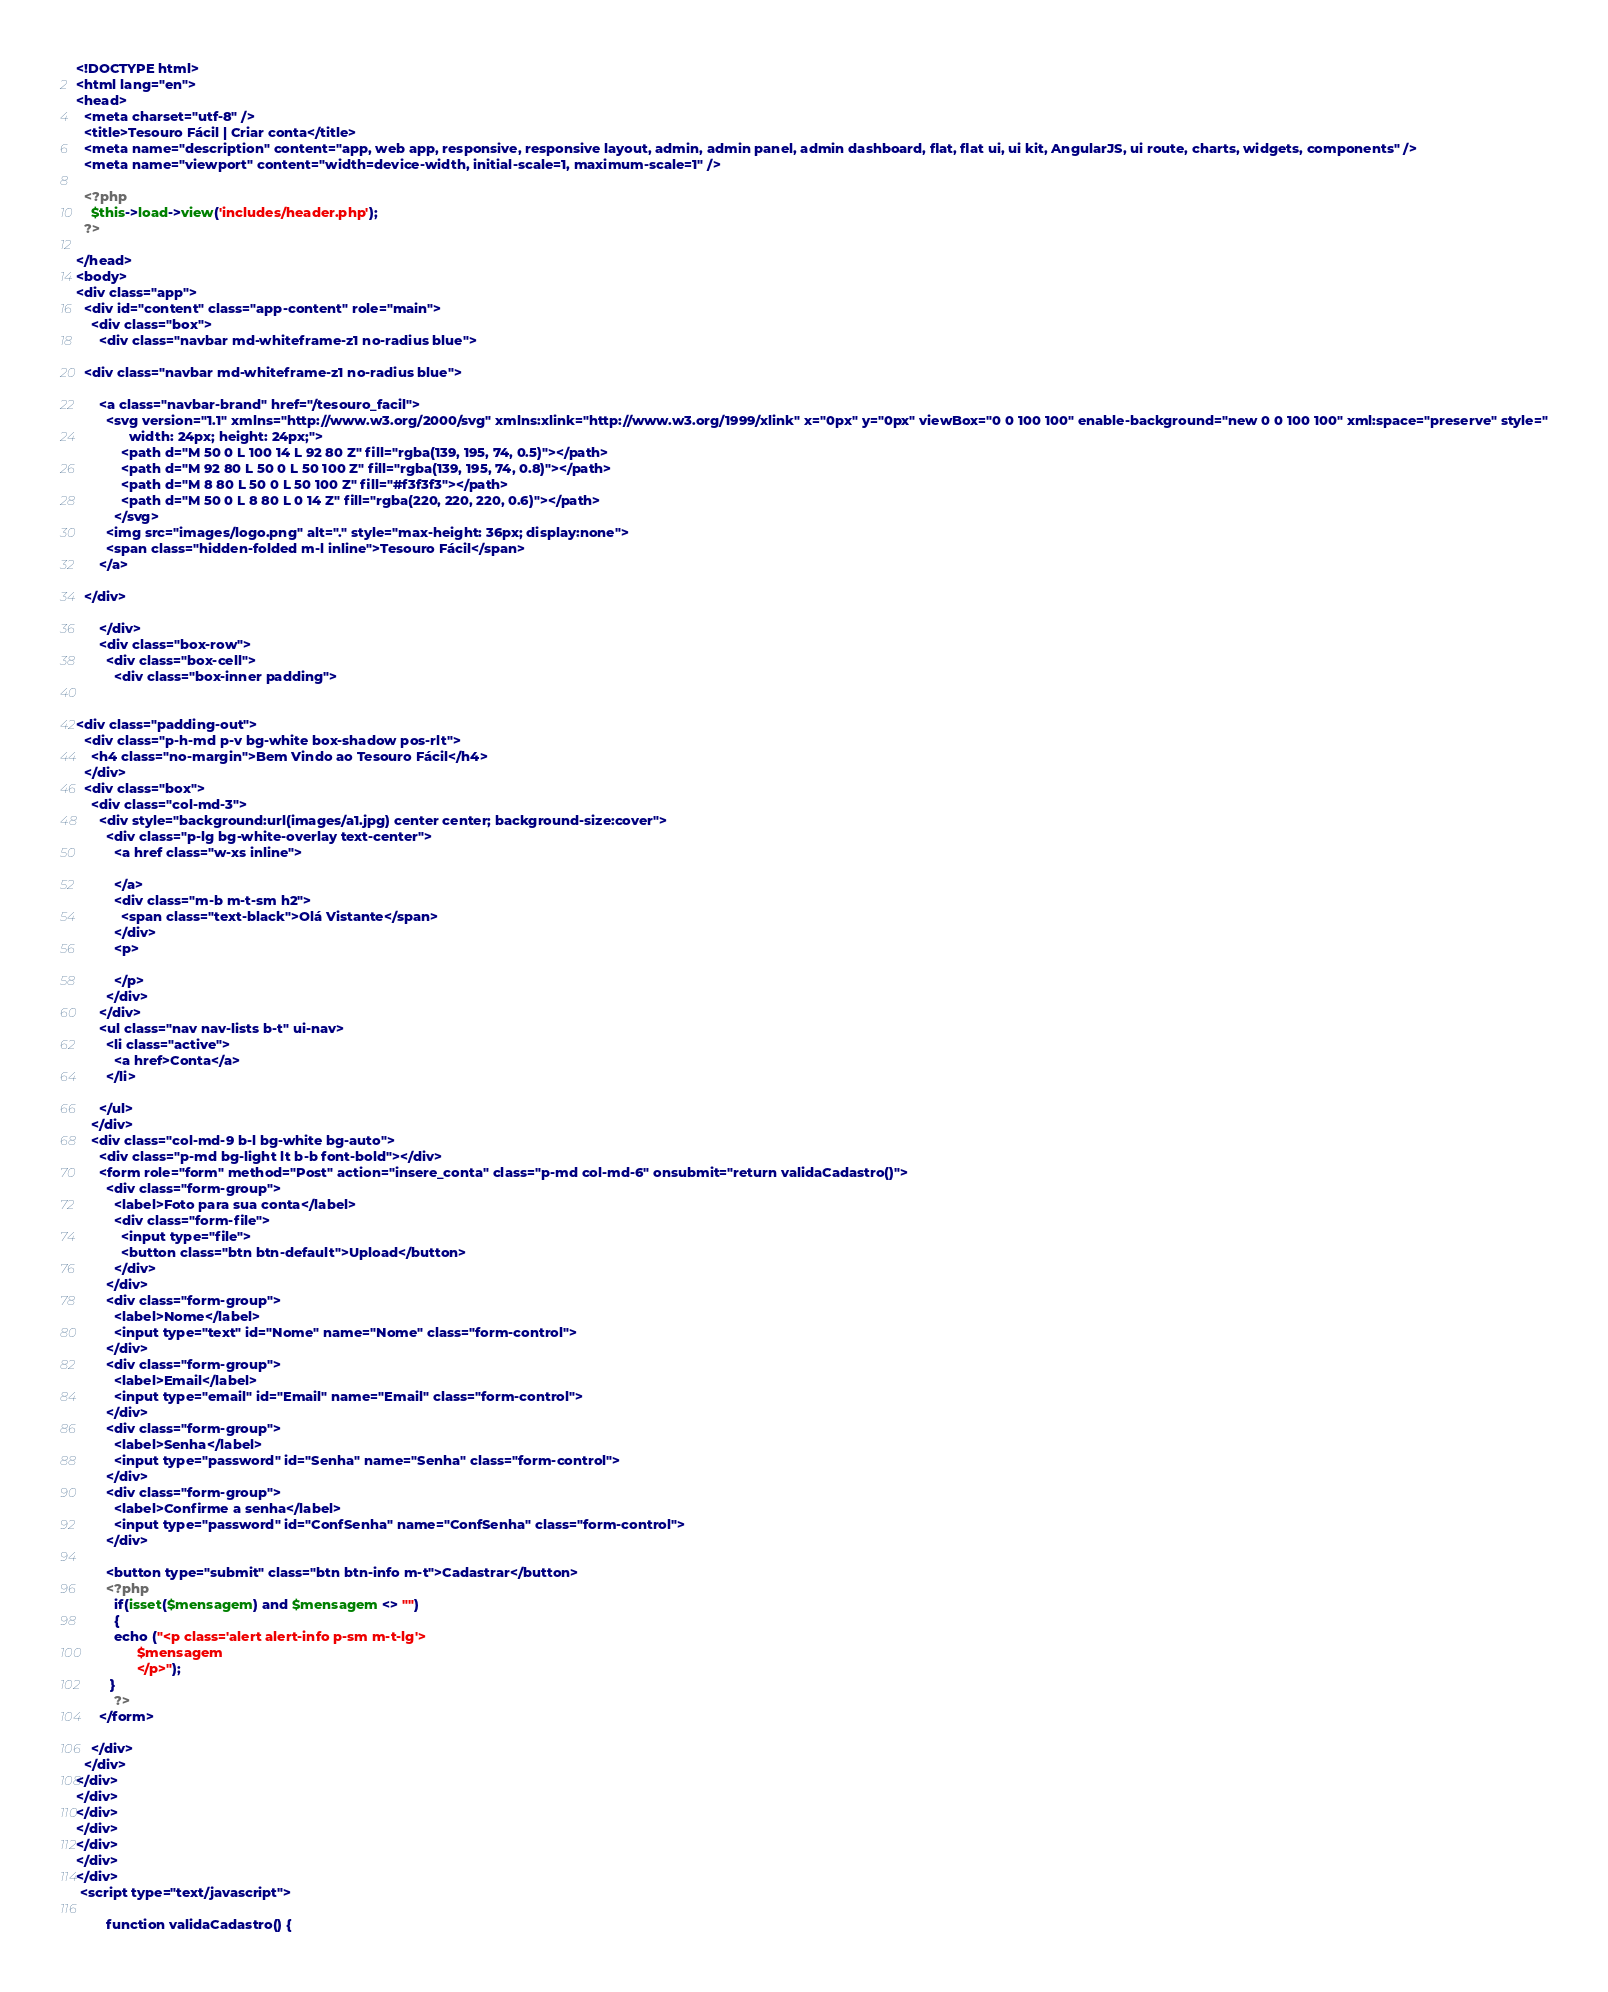<code> <loc_0><loc_0><loc_500><loc_500><_PHP_><!DOCTYPE html>
<html lang="en">
<head>
  <meta charset="utf-8" />
  <title>Tesouro Fácil | Criar conta</title>
  <meta name="description" content="app, web app, responsive, responsive layout, admin, admin panel, admin dashboard, flat, flat ui, ui kit, AngularJS, ui route, charts, widgets, components" />
  <meta name="viewport" content="width=device-width, initial-scale=1, maximum-scale=1" />

  <?php
    $this->load->view('includes/header.php');
  ?>

</head>
<body>
<div class="app">
  <div id="content" class="app-content" role="main">
    <div class="box">
      <div class="navbar md-whiteframe-z1 no-radius blue">

  <div class="navbar md-whiteframe-z1 no-radius blue">

      <a class="navbar-brand" href="/tesouro_facil">
        <svg version="1.1" xmlns="http://www.w3.org/2000/svg" xmlns:xlink="http://www.w3.org/1999/xlink" x="0px" y="0px" viewBox="0 0 100 100" enable-background="new 0 0 100 100" xml:space="preserve" style="
              width: 24px; height: 24px;">
            <path d="M 50 0 L 100 14 L 92 80 Z" fill="rgba(139, 195, 74, 0.5)"></path>
            <path d="M 92 80 L 50 0 L 50 100 Z" fill="rgba(139, 195, 74, 0.8)"></path>
            <path d="M 8 80 L 50 0 L 50 100 Z" fill="#f3f3f3"></path>
            <path d="M 50 0 L 8 80 L 0 14 Z" fill="rgba(220, 220, 220, 0.6)"></path>
          </svg>
        <img src="images/logo.png" alt="." style="max-height: 36px; display:none">
        <span class="hidden-folded m-l inline">Tesouro Fácil</span>
      </a>

  </div>

      </div>
      <div class="box-row">
        <div class="box-cell">
          <div class="box-inner padding">
            

<div class="padding-out">
  <div class="p-h-md p-v bg-white box-shadow pos-rlt">
    <h4 class="no-margin">Bem Vindo ao Tesouro Fácil</h4>
  </div>
  <div class="box">
    <div class="col-md-3">
      <div style="background:url(images/a1.jpg) center center; background-size:cover">
        <div class="p-lg bg-white-overlay text-center">
          <a href class="w-xs inline">
            
          </a>
          <div class="m-b m-t-sm h2">
            <span class="text-black">Olá Vistante</span>
          </div>
          <p>
            
          </p>
        </div>
      </div>
      <ul class="nav nav-lists b-t" ui-nav>
        <li class="active">
          <a href>Conta</a>
        </li>

      </ul>
    </div>
    <div class="col-md-9 b-l bg-white bg-auto">
      <div class="p-md bg-light lt b-b font-bold"></div>
      <form role="form" method="Post" action="insere_conta" class="p-md col-md-6" onsubmit="return validaCadastro()">
        <div class="form-group">
          <label>Foto para sua conta</label>
          <div class="form-file">
            <input type="file">
            <button class="btn btn-default">Upload</button>
          </div>
        </div>
        <div class="form-group">
          <label>Nome</label>
          <input type="text" id="Nome" name="Nome" class="form-control">
        </div>
        <div class="form-group">
          <label>Email</label>
          <input type="email" id="Email" name="Email" class="form-control">
        </div>
        <div class="form-group">
          <label>Senha</label>
          <input type="password" id="Senha" name="Senha" class="form-control">
        </div>
        <div class="form-group">
          <label>Confirme a senha</label>
          <input type="password" id="ConfSenha" name="ConfSenha" class="form-control">
        </div>
        
        <button type="submit" class="btn btn-info m-t">Cadastrar</button>
        <?php
          if(isset($mensagem) and $mensagem <> "")
          {
          echo ("<p class='alert alert-info p-sm m-t-lg'>
                $mensagem
                </p>");
         }
          ?>
      </form>

    </div>
  </div>
</div>
</div>
</div>
</div>
</div>
</div>
</div>
 <script type="text/javascript">

        function validaCadastro() {</code> 